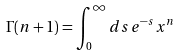Convert formula to latex. <formula><loc_0><loc_0><loc_500><loc_500>\Gamma ( n + 1 ) = \int _ { 0 } ^ { \infty } d s \, e ^ { - s } x ^ { n }</formula> 